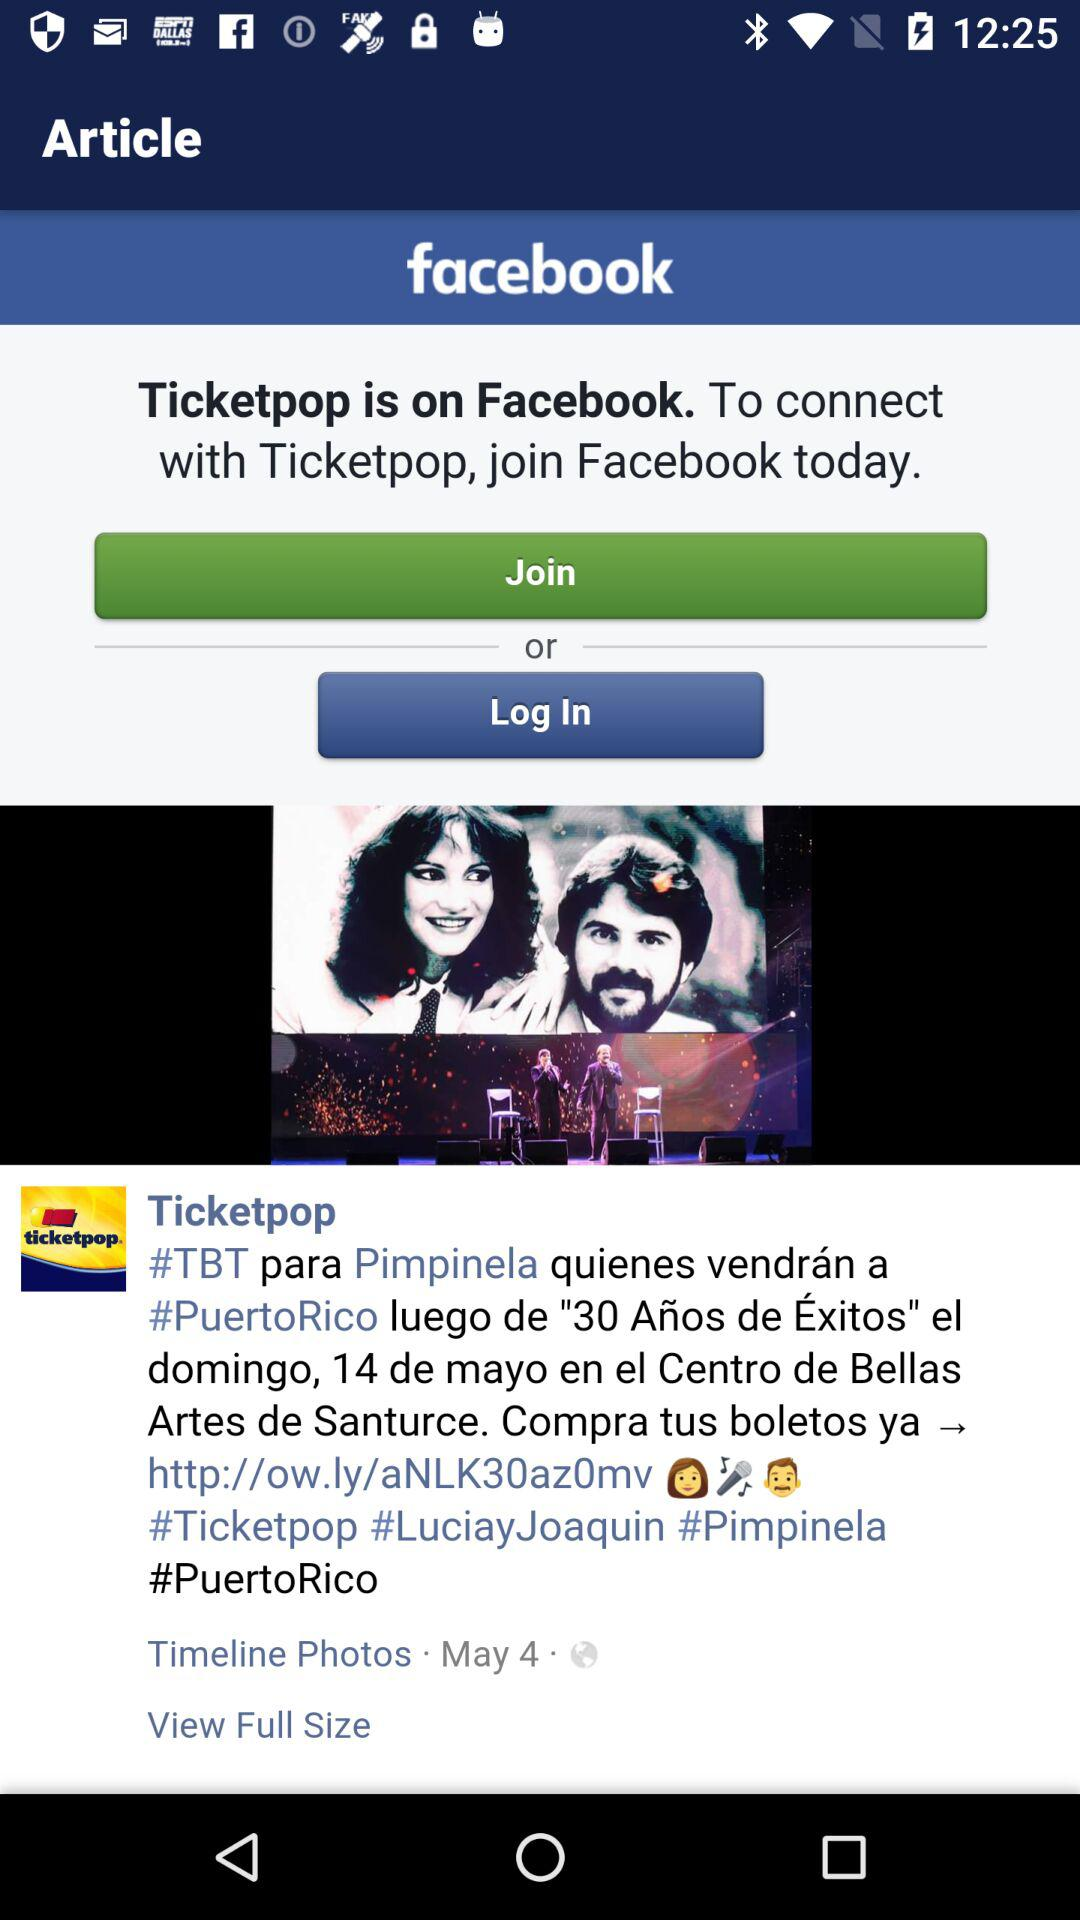On what date did Ticketpop share the post? Ticketpop shared the post on May 4. 